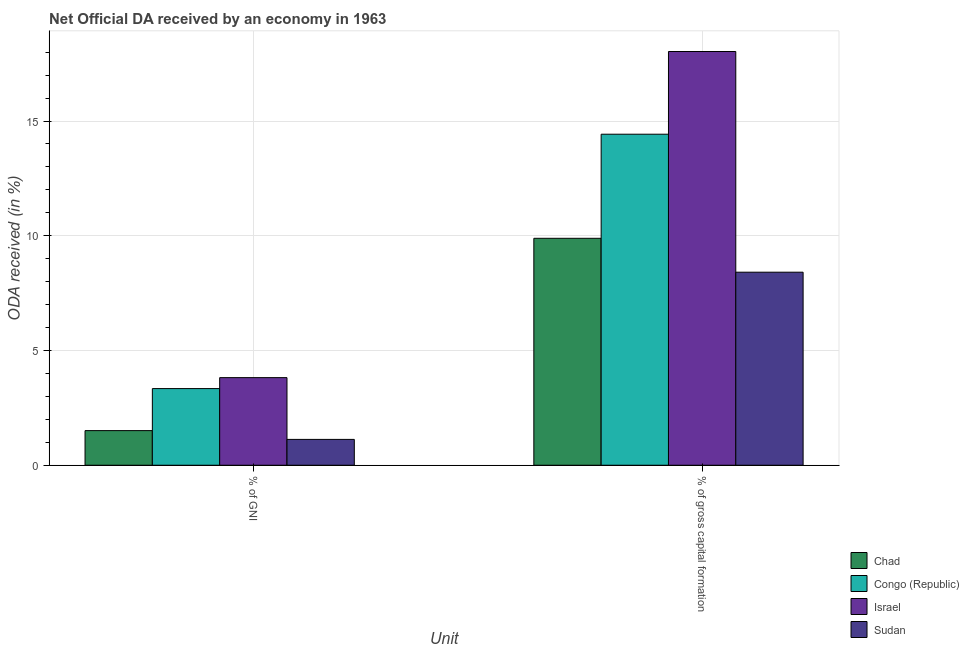How many groups of bars are there?
Make the answer very short. 2. Are the number of bars per tick equal to the number of legend labels?
Offer a very short reply. Yes. Are the number of bars on each tick of the X-axis equal?
Ensure brevity in your answer.  Yes. How many bars are there on the 2nd tick from the right?
Your response must be concise. 4. What is the label of the 2nd group of bars from the left?
Ensure brevity in your answer.  % of gross capital formation. What is the oda received as percentage of gni in Sudan?
Keep it short and to the point. 1.13. Across all countries, what is the maximum oda received as percentage of gross capital formation?
Your answer should be very brief. 18.03. Across all countries, what is the minimum oda received as percentage of gross capital formation?
Make the answer very short. 8.41. In which country was the oda received as percentage of gross capital formation maximum?
Your answer should be very brief. Israel. In which country was the oda received as percentage of gross capital formation minimum?
Your response must be concise. Sudan. What is the total oda received as percentage of gni in the graph?
Offer a very short reply. 9.79. What is the difference between the oda received as percentage of gni in Chad and that in Sudan?
Offer a terse response. 0.38. What is the difference between the oda received as percentage of gni in Sudan and the oda received as percentage of gross capital formation in Chad?
Make the answer very short. -8.76. What is the average oda received as percentage of gross capital formation per country?
Give a very brief answer. 12.69. What is the difference between the oda received as percentage of gross capital formation and oda received as percentage of gni in Congo (Republic)?
Make the answer very short. 11.09. What is the ratio of the oda received as percentage of gni in Congo (Republic) to that in Israel?
Provide a short and direct response. 0.87. Is the oda received as percentage of gni in Sudan less than that in Israel?
Offer a very short reply. Yes. In how many countries, is the oda received as percentage of gross capital formation greater than the average oda received as percentage of gross capital formation taken over all countries?
Give a very brief answer. 2. What does the 3rd bar from the left in % of GNI represents?
Make the answer very short. Israel. What does the 3rd bar from the right in % of GNI represents?
Provide a short and direct response. Congo (Republic). How many bars are there?
Offer a very short reply. 8. How many countries are there in the graph?
Make the answer very short. 4. Are the values on the major ticks of Y-axis written in scientific E-notation?
Your response must be concise. No. How many legend labels are there?
Keep it short and to the point. 4. What is the title of the graph?
Make the answer very short. Net Official DA received by an economy in 1963. What is the label or title of the X-axis?
Offer a very short reply. Unit. What is the label or title of the Y-axis?
Your answer should be compact. ODA received (in %). What is the ODA received (in %) of Chad in % of GNI?
Make the answer very short. 1.51. What is the ODA received (in %) in Congo (Republic) in % of GNI?
Provide a short and direct response. 3.34. What is the ODA received (in %) of Israel in % of GNI?
Give a very brief answer. 3.82. What is the ODA received (in %) of Sudan in % of GNI?
Ensure brevity in your answer.  1.13. What is the ODA received (in %) in Chad in % of gross capital formation?
Give a very brief answer. 9.89. What is the ODA received (in %) in Congo (Republic) in % of gross capital formation?
Give a very brief answer. 14.43. What is the ODA received (in %) in Israel in % of gross capital formation?
Provide a short and direct response. 18.03. What is the ODA received (in %) in Sudan in % of gross capital formation?
Make the answer very short. 8.41. Across all Unit, what is the maximum ODA received (in %) in Chad?
Give a very brief answer. 9.89. Across all Unit, what is the maximum ODA received (in %) in Congo (Republic)?
Offer a very short reply. 14.43. Across all Unit, what is the maximum ODA received (in %) of Israel?
Ensure brevity in your answer.  18.03. Across all Unit, what is the maximum ODA received (in %) in Sudan?
Provide a succinct answer. 8.41. Across all Unit, what is the minimum ODA received (in %) of Chad?
Ensure brevity in your answer.  1.51. Across all Unit, what is the minimum ODA received (in %) in Congo (Republic)?
Provide a succinct answer. 3.34. Across all Unit, what is the minimum ODA received (in %) of Israel?
Offer a very short reply. 3.82. Across all Unit, what is the minimum ODA received (in %) of Sudan?
Make the answer very short. 1.13. What is the total ODA received (in %) in Chad in the graph?
Your answer should be compact. 11.4. What is the total ODA received (in %) of Congo (Republic) in the graph?
Provide a short and direct response. 17.77. What is the total ODA received (in %) in Israel in the graph?
Provide a short and direct response. 21.85. What is the total ODA received (in %) of Sudan in the graph?
Provide a short and direct response. 9.54. What is the difference between the ODA received (in %) of Chad in % of GNI and that in % of gross capital formation?
Give a very brief answer. -8.38. What is the difference between the ODA received (in %) in Congo (Republic) in % of GNI and that in % of gross capital formation?
Keep it short and to the point. -11.09. What is the difference between the ODA received (in %) in Israel in % of GNI and that in % of gross capital formation?
Ensure brevity in your answer.  -14.21. What is the difference between the ODA received (in %) in Sudan in % of GNI and that in % of gross capital formation?
Give a very brief answer. -7.29. What is the difference between the ODA received (in %) of Chad in % of GNI and the ODA received (in %) of Congo (Republic) in % of gross capital formation?
Ensure brevity in your answer.  -12.92. What is the difference between the ODA received (in %) of Chad in % of GNI and the ODA received (in %) of Israel in % of gross capital formation?
Offer a very short reply. -16.52. What is the difference between the ODA received (in %) in Chad in % of GNI and the ODA received (in %) in Sudan in % of gross capital formation?
Your response must be concise. -6.9. What is the difference between the ODA received (in %) in Congo (Republic) in % of GNI and the ODA received (in %) in Israel in % of gross capital formation?
Offer a very short reply. -14.69. What is the difference between the ODA received (in %) in Congo (Republic) in % of GNI and the ODA received (in %) in Sudan in % of gross capital formation?
Give a very brief answer. -5.07. What is the difference between the ODA received (in %) of Israel in % of GNI and the ODA received (in %) of Sudan in % of gross capital formation?
Make the answer very short. -4.59. What is the average ODA received (in %) in Chad per Unit?
Provide a succinct answer. 5.7. What is the average ODA received (in %) in Congo (Republic) per Unit?
Make the answer very short. 8.88. What is the average ODA received (in %) in Israel per Unit?
Offer a very short reply. 10.92. What is the average ODA received (in %) in Sudan per Unit?
Give a very brief answer. 4.77. What is the difference between the ODA received (in %) of Chad and ODA received (in %) of Congo (Republic) in % of GNI?
Keep it short and to the point. -1.83. What is the difference between the ODA received (in %) in Chad and ODA received (in %) in Israel in % of GNI?
Provide a short and direct response. -2.31. What is the difference between the ODA received (in %) of Chad and ODA received (in %) of Sudan in % of GNI?
Your response must be concise. 0.38. What is the difference between the ODA received (in %) of Congo (Republic) and ODA received (in %) of Israel in % of GNI?
Make the answer very short. -0.48. What is the difference between the ODA received (in %) of Congo (Republic) and ODA received (in %) of Sudan in % of GNI?
Make the answer very short. 2.21. What is the difference between the ODA received (in %) in Israel and ODA received (in %) in Sudan in % of GNI?
Give a very brief answer. 2.69. What is the difference between the ODA received (in %) in Chad and ODA received (in %) in Congo (Republic) in % of gross capital formation?
Provide a succinct answer. -4.54. What is the difference between the ODA received (in %) in Chad and ODA received (in %) in Israel in % of gross capital formation?
Your response must be concise. -8.14. What is the difference between the ODA received (in %) in Chad and ODA received (in %) in Sudan in % of gross capital formation?
Your answer should be very brief. 1.48. What is the difference between the ODA received (in %) in Congo (Republic) and ODA received (in %) in Israel in % of gross capital formation?
Make the answer very short. -3.6. What is the difference between the ODA received (in %) of Congo (Republic) and ODA received (in %) of Sudan in % of gross capital formation?
Keep it short and to the point. 6.01. What is the difference between the ODA received (in %) of Israel and ODA received (in %) of Sudan in % of gross capital formation?
Offer a very short reply. 9.62. What is the ratio of the ODA received (in %) of Chad in % of GNI to that in % of gross capital formation?
Offer a terse response. 0.15. What is the ratio of the ODA received (in %) in Congo (Republic) in % of GNI to that in % of gross capital formation?
Your response must be concise. 0.23. What is the ratio of the ODA received (in %) of Israel in % of GNI to that in % of gross capital formation?
Your answer should be very brief. 0.21. What is the ratio of the ODA received (in %) in Sudan in % of GNI to that in % of gross capital formation?
Give a very brief answer. 0.13. What is the difference between the highest and the second highest ODA received (in %) in Chad?
Give a very brief answer. 8.38. What is the difference between the highest and the second highest ODA received (in %) of Congo (Republic)?
Keep it short and to the point. 11.09. What is the difference between the highest and the second highest ODA received (in %) of Israel?
Provide a short and direct response. 14.21. What is the difference between the highest and the second highest ODA received (in %) of Sudan?
Give a very brief answer. 7.29. What is the difference between the highest and the lowest ODA received (in %) in Chad?
Ensure brevity in your answer.  8.38. What is the difference between the highest and the lowest ODA received (in %) of Congo (Republic)?
Offer a terse response. 11.09. What is the difference between the highest and the lowest ODA received (in %) in Israel?
Ensure brevity in your answer.  14.21. What is the difference between the highest and the lowest ODA received (in %) in Sudan?
Your response must be concise. 7.29. 